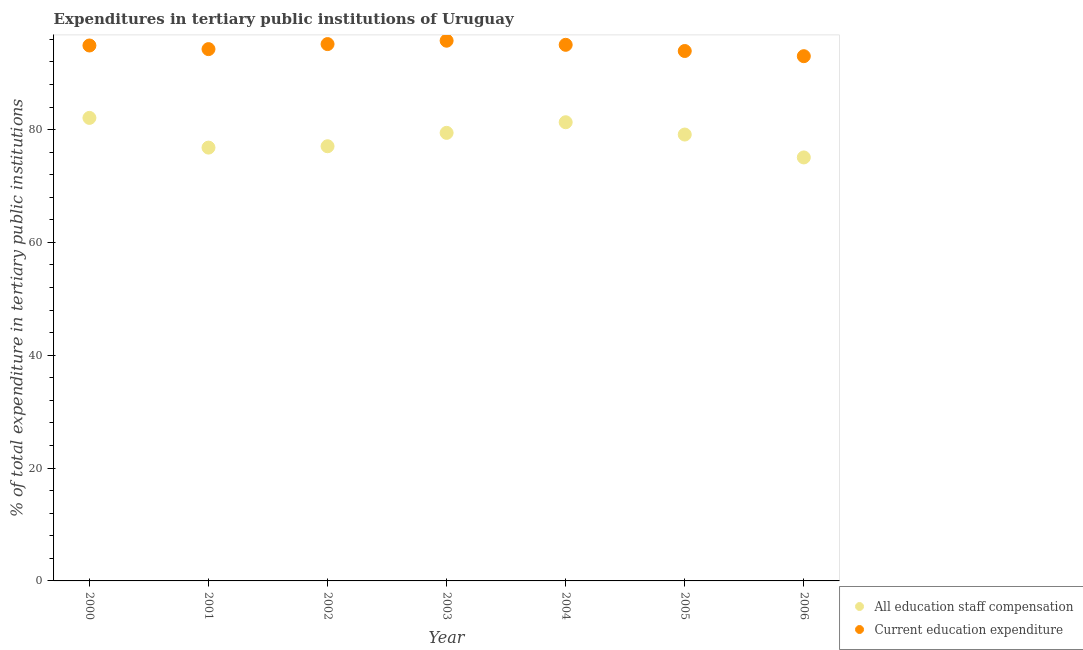What is the expenditure in education in 2000?
Provide a short and direct response. 94.9. Across all years, what is the maximum expenditure in education?
Give a very brief answer. 95.75. Across all years, what is the minimum expenditure in education?
Provide a succinct answer. 93.01. In which year was the expenditure in staff compensation maximum?
Provide a succinct answer. 2000. What is the total expenditure in staff compensation in the graph?
Provide a succinct answer. 550.81. What is the difference between the expenditure in staff compensation in 2001 and that in 2003?
Your response must be concise. -2.61. What is the difference between the expenditure in education in 2000 and the expenditure in staff compensation in 2004?
Keep it short and to the point. 13.6. What is the average expenditure in education per year?
Make the answer very short. 94.57. In the year 2004, what is the difference between the expenditure in staff compensation and expenditure in education?
Make the answer very short. -13.72. What is the ratio of the expenditure in education in 2000 to that in 2004?
Your response must be concise. 1. Is the expenditure in education in 2002 less than that in 2005?
Ensure brevity in your answer.  No. Is the difference between the expenditure in staff compensation in 2002 and 2004 greater than the difference between the expenditure in education in 2002 and 2004?
Provide a succinct answer. No. What is the difference between the highest and the second highest expenditure in education?
Provide a succinct answer. 0.6. What is the difference between the highest and the lowest expenditure in staff compensation?
Provide a succinct answer. 7.01. Does the expenditure in staff compensation monotonically increase over the years?
Ensure brevity in your answer.  No. Is the expenditure in staff compensation strictly greater than the expenditure in education over the years?
Keep it short and to the point. No. Is the expenditure in education strictly less than the expenditure in staff compensation over the years?
Provide a succinct answer. No. How many dotlines are there?
Your answer should be very brief. 2. Are the values on the major ticks of Y-axis written in scientific E-notation?
Provide a succinct answer. No. Does the graph contain any zero values?
Give a very brief answer. No. Where does the legend appear in the graph?
Offer a terse response. Bottom right. What is the title of the graph?
Provide a short and direct response. Expenditures in tertiary public institutions of Uruguay. What is the label or title of the Y-axis?
Your answer should be very brief. % of total expenditure in tertiary public institutions. What is the % of total expenditure in tertiary public institutions of All education staff compensation in 2000?
Your response must be concise. 82.07. What is the % of total expenditure in tertiary public institutions in Current education expenditure in 2000?
Your answer should be very brief. 94.9. What is the % of total expenditure in tertiary public institutions of All education staff compensation in 2001?
Your answer should be very brief. 76.8. What is the % of total expenditure in tertiary public institutions of Current education expenditure in 2001?
Make the answer very short. 94.26. What is the % of total expenditure in tertiary public institutions of All education staff compensation in 2002?
Offer a terse response. 77.05. What is the % of total expenditure in tertiary public institutions of Current education expenditure in 2002?
Offer a very short reply. 95.15. What is the % of total expenditure in tertiary public institutions in All education staff compensation in 2003?
Make the answer very short. 79.42. What is the % of total expenditure in tertiary public institutions in Current education expenditure in 2003?
Give a very brief answer. 95.75. What is the % of total expenditure in tertiary public institutions of All education staff compensation in 2004?
Give a very brief answer. 81.3. What is the % of total expenditure in tertiary public institutions in Current education expenditure in 2004?
Provide a short and direct response. 95.02. What is the % of total expenditure in tertiary public institutions in All education staff compensation in 2005?
Give a very brief answer. 79.12. What is the % of total expenditure in tertiary public institutions in Current education expenditure in 2005?
Keep it short and to the point. 93.93. What is the % of total expenditure in tertiary public institutions of All education staff compensation in 2006?
Provide a short and direct response. 75.06. What is the % of total expenditure in tertiary public institutions in Current education expenditure in 2006?
Offer a very short reply. 93.01. Across all years, what is the maximum % of total expenditure in tertiary public institutions in All education staff compensation?
Ensure brevity in your answer.  82.07. Across all years, what is the maximum % of total expenditure in tertiary public institutions of Current education expenditure?
Offer a very short reply. 95.75. Across all years, what is the minimum % of total expenditure in tertiary public institutions in All education staff compensation?
Your response must be concise. 75.06. Across all years, what is the minimum % of total expenditure in tertiary public institutions in Current education expenditure?
Your response must be concise. 93.01. What is the total % of total expenditure in tertiary public institutions of All education staff compensation in the graph?
Keep it short and to the point. 550.81. What is the total % of total expenditure in tertiary public institutions of Current education expenditure in the graph?
Make the answer very short. 662.02. What is the difference between the % of total expenditure in tertiary public institutions in All education staff compensation in 2000 and that in 2001?
Make the answer very short. 5.27. What is the difference between the % of total expenditure in tertiary public institutions of Current education expenditure in 2000 and that in 2001?
Provide a succinct answer. 0.64. What is the difference between the % of total expenditure in tertiary public institutions in All education staff compensation in 2000 and that in 2002?
Your response must be concise. 5.02. What is the difference between the % of total expenditure in tertiary public institutions of Current education expenditure in 2000 and that in 2002?
Your response must be concise. -0.25. What is the difference between the % of total expenditure in tertiary public institutions in All education staff compensation in 2000 and that in 2003?
Provide a short and direct response. 2.65. What is the difference between the % of total expenditure in tertiary public institutions of Current education expenditure in 2000 and that in 2003?
Give a very brief answer. -0.85. What is the difference between the % of total expenditure in tertiary public institutions of All education staff compensation in 2000 and that in 2004?
Your answer should be very brief. 0.77. What is the difference between the % of total expenditure in tertiary public institutions of Current education expenditure in 2000 and that in 2004?
Offer a very short reply. -0.12. What is the difference between the % of total expenditure in tertiary public institutions of All education staff compensation in 2000 and that in 2005?
Give a very brief answer. 2.95. What is the difference between the % of total expenditure in tertiary public institutions of Current education expenditure in 2000 and that in 2005?
Give a very brief answer. 0.98. What is the difference between the % of total expenditure in tertiary public institutions of All education staff compensation in 2000 and that in 2006?
Provide a succinct answer. 7.01. What is the difference between the % of total expenditure in tertiary public institutions of Current education expenditure in 2000 and that in 2006?
Give a very brief answer. 1.89. What is the difference between the % of total expenditure in tertiary public institutions in All education staff compensation in 2001 and that in 2002?
Make the answer very short. -0.24. What is the difference between the % of total expenditure in tertiary public institutions of Current education expenditure in 2001 and that in 2002?
Keep it short and to the point. -0.89. What is the difference between the % of total expenditure in tertiary public institutions of All education staff compensation in 2001 and that in 2003?
Ensure brevity in your answer.  -2.61. What is the difference between the % of total expenditure in tertiary public institutions of Current education expenditure in 2001 and that in 2003?
Provide a short and direct response. -1.49. What is the difference between the % of total expenditure in tertiary public institutions of All education staff compensation in 2001 and that in 2004?
Your answer should be compact. -4.5. What is the difference between the % of total expenditure in tertiary public institutions of Current education expenditure in 2001 and that in 2004?
Your answer should be very brief. -0.76. What is the difference between the % of total expenditure in tertiary public institutions of All education staff compensation in 2001 and that in 2005?
Provide a short and direct response. -2.32. What is the difference between the % of total expenditure in tertiary public institutions in Current education expenditure in 2001 and that in 2005?
Your answer should be compact. 0.33. What is the difference between the % of total expenditure in tertiary public institutions in All education staff compensation in 2001 and that in 2006?
Offer a very short reply. 1.74. What is the difference between the % of total expenditure in tertiary public institutions in Current education expenditure in 2001 and that in 2006?
Give a very brief answer. 1.25. What is the difference between the % of total expenditure in tertiary public institutions in All education staff compensation in 2002 and that in 2003?
Your response must be concise. -2.37. What is the difference between the % of total expenditure in tertiary public institutions of Current education expenditure in 2002 and that in 2003?
Offer a very short reply. -0.6. What is the difference between the % of total expenditure in tertiary public institutions of All education staff compensation in 2002 and that in 2004?
Offer a very short reply. -4.25. What is the difference between the % of total expenditure in tertiary public institutions in Current education expenditure in 2002 and that in 2004?
Ensure brevity in your answer.  0.13. What is the difference between the % of total expenditure in tertiary public institutions of All education staff compensation in 2002 and that in 2005?
Your response must be concise. -2.07. What is the difference between the % of total expenditure in tertiary public institutions of Current education expenditure in 2002 and that in 2005?
Ensure brevity in your answer.  1.23. What is the difference between the % of total expenditure in tertiary public institutions in All education staff compensation in 2002 and that in 2006?
Ensure brevity in your answer.  1.99. What is the difference between the % of total expenditure in tertiary public institutions in Current education expenditure in 2002 and that in 2006?
Your answer should be compact. 2.14. What is the difference between the % of total expenditure in tertiary public institutions in All education staff compensation in 2003 and that in 2004?
Your answer should be compact. -1.88. What is the difference between the % of total expenditure in tertiary public institutions in Current education expenditure in 2003 and that in 2004?
Your response must be concise. 0.73. What is the difference between the % of total expenditure in tertiary public institutions in All education staff compensation in 2003 and that in 2005?
Make the answer very short. 0.3. What is the difference between the % of total expenditure in tertiary public institutions in Current education expenditure in 2003 and that in 2005?
Make the answer very short. 1.82. What is the difference between the % of total expenditure in tertiary public institutions of All education staff compensation in 2003 and that in 2006?
Keep it short and to the point. 4.36. What is the difference between the % of total expenditure in tertiary public institutions in Current education expenditure in 2003 and that in 2006?
Your response must be concise. 2.74. What is the difference between the % of total expenditure in tertiary public institutions in All education staff compensation in 2004 and that in 2005?
Your answer should be compact. 2.18. What is the difference between the % of total expenditure in tertiary public institutions in Current education expenditure in 2004 and that in 2005?
Make the answer very short. 1.1. What is the difference between the % of total expenditure in tertiary public institutions of All education staff compensation in 2004 and that in 2006?
Ensure brevity in your answer.  6.24. What is the difference between the % of total expenditure in tertiary public institutions of Current education expenditure in 2004 and that in 2006?
Your answer should be very brief. 2.01. What is the difference between the % of total expenditure in tertiary public institutions of All education staff compensation in 2005 and that in 2006?
Provide a succinct answer. 4.06. What is the difference between the % of total expenditure in tertiary public institutions in Current education expenditure in 2005 and that in 2006?
Your response must be concise. 0.92. What is the difference between the % of total expenditure in tertiary public institutions of All education staff compensation in 2000 and the % of total expenditure in tertiary public institutions of Current education expenditure in 2001?
Your answer should be compact. -12.19. What is the difference between the % of total expenditure in tertiary public institutions in All education staff compensation in 2000 and the % of total expenditure in tertiary public institutions in Current education expenditure in 2002?
Keep it short and to the point. -13.08. What is the difference between the % of total expenditure in tertiary public institutions of All education staff compensation in 2000 and the % of total expenditure in tertiary public institutions of Current education expenditure in 2003?
Provide a short and direct response. -13.68. What is the difference between the % of total expenditure in tertiary public institutions in All education staff compensation in 2000 and the % of total expenditure in tertiary public institutions in Current education expenditure in 2004?
Ensure brevity in your answer.  -12.95. What is the difference between the % of total expenditure in tertiary public institutions of All education staff compensation in 2000 and the % of total expenditure in tertiary public institutions of Current education expenditure in 2005?
Make the answer very short. -11.86. What is the difference between the % of total expenditure in tertiary public institutions of All education staff compensation in 2000 and the % of total expenditure in tertiary public institutions of Current education expenditure in 2006?
Your answer should be very brief. -10.94. What is the difference between the % of total expenditure in tertiary public institutions of All education staff compensation in 2001 and the % of total expenditure in tertiary public institutions of Current education expenditure in 2002?
Your answer should be very brief. -18.35. What is the difference between the % of total expenditure in tertiary public institutions in All education staff compensation in 2001 and the % of total expenditure in tertiary public institutions in Current education expenditure in 2003?
Keep it short and to the point. -18.95. What is the difference between the % of total expenditure in tertiary public institutions of All education staff compensation in 2001 and the % of total expenditure in tertiary public institutions of Current education expenditure in 2004?
Provide a succinct answer. -18.22. What is the difference between the % of total expenditure in tertiary public institutions in All education staff compensation in 2001 and the % of total expenditure in tertiary public institutions in Current education expenditure in 2005?
Give a very brief answer. -17.12. What is the difference between the % of total expenditure in tertiary public institutions of All education staff compensation in 2001 and the % of total expenditure in tertiary public institutions of Current education expenditure in 2006?
Keep it short and to the point. -16.21. What is the difference between the % of total expenditure in tertiary public institutions in All education staff compensation in 2002 and the % of total expenditure in tertiary public institutions in Current education expenditure in 2003?
Give a very brief answer. -18.7. What is the difference between the % of total expenditure in tertiary public institutions of All education staff compensation in 2002 and the % of total expenditure in tertiary public institutions of Current education expenditure in 2004?
Ensure brevity in your answer.  -17.98. What is the difference between the % of total expenditure in tertiary public institutions of All education staff compensation in 2002 and the % of total expenditure in tertiary public institutions of Current education expenditure in 2005?
Your answer should be compact. -16.88. What is the difference between the % of total expenditure in tertiary public institutions of All education staff compensation in 2002 and the % of total expenditure in tertiary public institutions of Current education expenditure in 2006?
Give a very brief answer. -15.96. What is the difference between the % of total expenditure in tertiary public institutions of All education staff compensation in 2003 and the % of total expenditure in tertiary public institutions of Current education expenditure in 2004?
Provide a succinct answer. -15.61. What is the difference between the % of total expenditure in tertiary public institutions in All education staff compensation in 2003 and the % of total expenditure in tertiary public institutions in Current education expenditure in 2005?
Make the answer very short. -14.51. What is the difference between the % of total expenditure in tertiary public institutions in All education staff compensation in 2003 and the % of total expenditure in tertiary public institutions in Current education expenditure in 2006?
Your answer should be compact. -13.59. What is the difference between the % of total expenditure in tertiary public institutions in All education staff compensation in 2004 and the % of total expenditure in tertiary public institutions in Current education expenditure in 2005?
Keep it short and to the point. -12.63. What is the difference between the % of total expenditure in tertiary public institutions in All education staff compensation in 2004 and the % of total expenditure in tertiary public institutions in Current education expenditure in 2006?
Provide a short and direct response. -11.71. What is the difference between the % of total expenditure in tertiary public institutions of All education staff compensation in 2005 and the % of total expenditure in tertiary public institutions of Current education expenditure in 2006?
Ensure brevity in your answer.  -13.89. What is the average % of total expenditure in tertiary public institutions of All education staff compensation per year?
Your response must be concise. 78.69. What is the average % of total expenditure in tertiary public institutions of Current education expenditure per year?
Your answer should be very brief. 94.57. In the year 2000, what is the difference between the % of total expenditure in tertiary public institutions in All education staff compensation and % of total expenditure in tertiary public institutions in Current education expenditure?
Ensure brevity in your answer.  -12.83. In the year 2001, what is the difference between the % of total expenditure in tertiary public institutions of All education staff compensation and % of total expenditure in tertiary public institutions of Current education expenditure?
Your response must be concise. -17.46. In the year 2002, what is the difference between the % of total expenditure in tertiary public institutions of All education staff compensation and % of total expenditure in tertiary public institutions of Current education expenditure?
Make the answer very short. -18.11. In the year 2003, what is the difference between the % of total expenditure in tertiary public institutions in All education staff compensation and % of total expenditure in tertiary public institutions in Current education expenditure?
Give a very brief answer. -16.33. In the year 2004, what is the difference between the % of total expenditure in tertiary public institutions of All education staff compensation and % of total expenditure in tertiary public institutions of Current education expenditure?
Your answer should be compact. -13.72. In the year 2005, what is the difference between the % of total expenditure in tertiary public institutions in All education staff compensation and % of total expenditure in tertiary public institutions in Current education expenditure?
Make the answer very short. -14.81. In the year 2006, what is the difference between the % of total expenditure in tertiary public institutions in All education staff compensation and % of total expenditure in tertiary public institutions in Current education expenditure?
Offer a very short reply. -17.95. What is the ratio of the % of total expenditure in tertiary public institutions of All education staff compensation in 2000 to that in 2001?
Offer a very short reply. 1.07. What is the ratio of the % of total expenditure in tertiary public institutions in Current education expenditure in 2000 to that in 2001?
Your answer should be very brief. 1.01. What is the ratio of the % of total expenditure in tertiary public institutions of All education staff compensation in 2000 to that in 2002?
Your answer should be compact. 1.07. What is the ratio of the % of total expenditure in tertiary public institutions of All education staff compensation in 2000 to that in 2003?
Offer a very short reply. 1.03. What is the ratio of the % of total expenditure in tertiary public institutions of All education staff compensation in 2000 to that in 2004?
Keep it short and to the point. 1.01. What is the ratio of the % of total expenditure in tertiary public institutions of Current education expenditure in 2000 to that in 2004?
Offer a terse response. 1. What is the ratio of the % of total expenditure in tertiary public institutions of All education staff compensation in 2000 to that in 2005?
Your answer should be very brief. 1.04. What is the ratio of the % of total expenditure in tertiary public institutions in Current education expenditure in 2000 to that in 2005?
Your answer should be compact. 1.01. What is the ratio of the % of total expenditure in tertiary public institutions in All education staff compensation in 2000 to that in 2006?
Provide a short and direct response. 1.09. What is the ratio of the % of total expenditure in tertiary public institutions in Current education expenditure in 2000 to that in 2006?
Your answer should be compact. 1.02. What is the ratio of the % of total expenditure in tertiary public institutions in Current education expenditure in 2001 to that in 2002?
Your answer should be compact. 0.99. What is the ratio of the % of total expenditure in tertiary public institutions of All education staff compensation in 2001 to that in 2003?
Make the answer very short. 0.97. What is the ratio of the % of total expenditure in tertiary public institutions of Current education expenditure in 2001 to that in 2003?
Ensure brevity in your answer.  0.98. What is the ratio of the % of total expenditure in tertiary public institutions of All education staff compensation in 2001 to that in 2004?
Provide a short and direct response. 0.94. What is the ratio of the % of total expenditure in tertiary public institutions of All education staff compensation in 2001 to that in 2005?
Offer a terse response. 0.97. What is the ratio of the % of total expenditure in tertiary public institutions in All education staff compensation in 2001 to that in 2006?
Your answer should be compact. 1.02. What is the ratio of the % of total expenditure in tertiary public institutions of Current education expenditure in 2001 to that in 2006?
Provide a short and direct response. 1.01. What is the ratio of the % of total expenditure in tertiary public institutions of All education staff compensation in 2002 to that in 2003?
Your answer should be very brief. 0.97. What is the ratio of the % of total expenditure in tertiary public institutions of Current education expenditure in 2002 to that in 2003?
Ensure brevity in your answer.  0.99. What is the ratio of the % of total expenditure in tertiary public institutions in All education staff compensation in 2002 to that in 2004?
Provide a short and direct response. 0.95. What is the ratio of the % of total expenditure in tertiary public institutions of Current education expenditure in 2002 to that in 2004?
Your answer should be very brief. 1. What is the ratio of the % of total expenditure in tertiary public institutions in All education staff compensation in 2002 to that in 2005?
Your answer should be very brief. 0.97. What is the ratio of the % of total expenditure in tertiary public institutions of Current education expenditure in 2002 to that in 2005?
Your response must be concise. 1.01. What is the ratio of the % of total expenditure in tertiary public institutions of All education staff compensation in 2002 to that in 2006?
Your answer should be very brief. 1.03. What is the ratio of the % of total expenditure in tertiary public institutions in Current education expenditure in 2002 to that in 2006?
Your response must be concise. 1.02. What is the ratio of the % of total expenditure in tertiary public institutions in All education staff compensation in 2003 to that in 2004?
Ensure brevity in your answer.  0.98. What is the ratio of the % of total expenditure in tertiary public institutions in Current education expenditure in 2003 to that in 2004?
Your answer should be very brief. 1.01. What is the ratio of the % of total expenditure in tertiary public institutions of All education staff compensation in 2003 to that in 2005?
Give a very brief answer. 1. What is the ratio of the % of total expenditure in tertiary public institutions of Current education expenditure in 2003 to that in 2005?
Offer a very short reply. 1.02. What is the ratio of the % of total expenditure in tertiary public institutions in All education staff compensation in 2003 to that in 2006?
Give a very brief answer. 1.06. What is the ratio of the % of total expenditure in tertiary public institutions of Current education expenditure in 2003 to that in 2006?
Ensure brevity in your answer.  1.03. What is the ratio of the % of total expenditure in tertiary public institutions of All education staff compensation in 2004 to that in 2005?
Your response must be concise. 1.03. What is the ratio of the % of total expenditure in tertiary public institutions of Current education expenditure in 2004 to that in 2005?
Offer a terse response. 1.01. What is the ratio of the % of total expenditure in tertiary public institutions of All education staff compensation in 2004 to that in 2006?
Provide a succinct answer. 1.08. What is the ratio of the % of total expenditure in tertiary public institutions of Current education expenditure in 2004 to that in 2006?
Offer a very short reply. 1.02. What is the ratio of the % of total expenditure in tertiary public institutions of All education staff compensation in 2005 to that in 2006?
Provide a succinct answer. 1.05. What is the ratio of the % of total expenditure in tertiary public institutions in Current education expenditure in 2005 to that in 2006?
Make the answer very short. 1.01. What is the difference between the highest and the second highest % of total expenditure in tertiary public institutions in All education staff compensation?
Give a very brief answer. 0.77. What is the difference between the highest and the second highest % of total expenditure in tertiary public institutions of Current education expenditure?
Keep it short and to the point. 0.6. What is the difference between the highest and the lowest % of total expenditure in tertiary public institutions of All education staff compensation?
Give a very brief answer. 7.01. What is the difference between the highest and the lowest % of total expenditure in tertiary public institutions in Current education expenditure?
Provide a succinct answer. 2.74. 